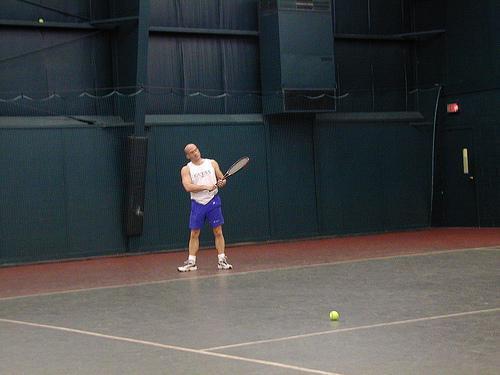How many tennis balls are there?
Give a very brief answer. 1. 